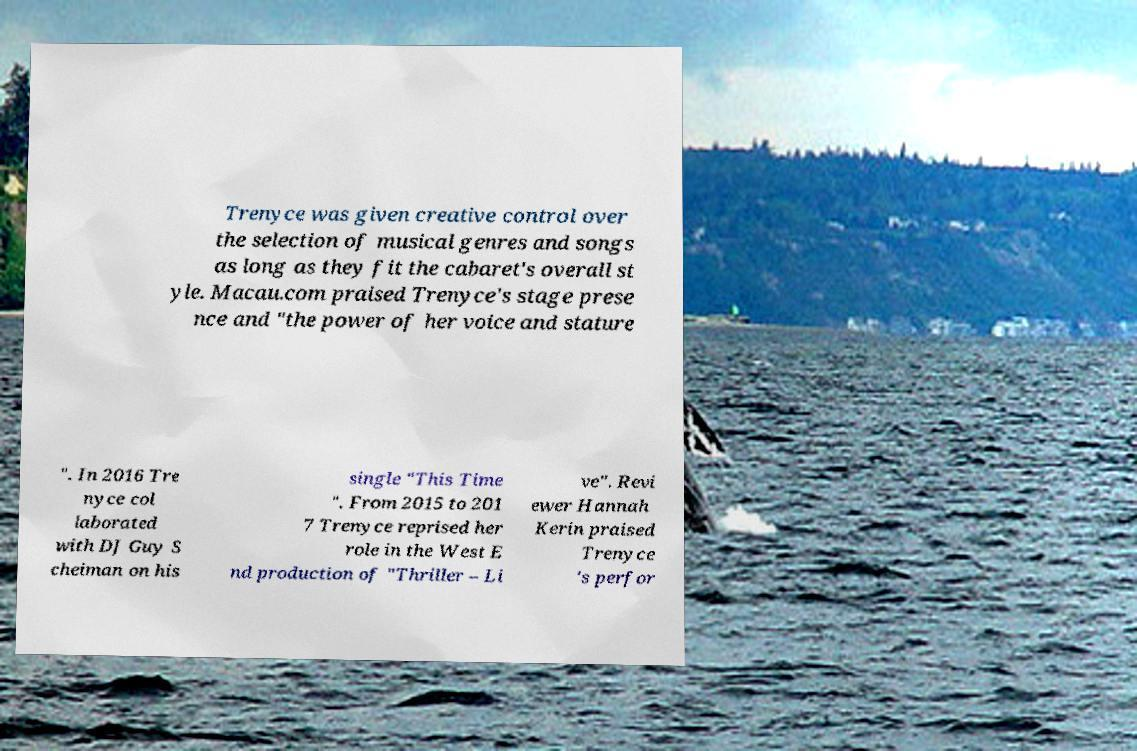Can you accurately transcribe the text from the provided image for me? Trenyce was given creative control over the selection of musical genres and songs as long as they fit the cabaret's overall st yle. Macau.com praised Trenyce's stage prese nce and "the power of her voice and stature ". In 2016 Tre nyce col laborated with DJ Guy S cheiman on his single "This Time ". From 2015 to 201 7 Trenyce reprised her role in the West E nd production of "Thriller – Li ve". Revi ewer Hannah Kerin praised Trenyce 's perfor 